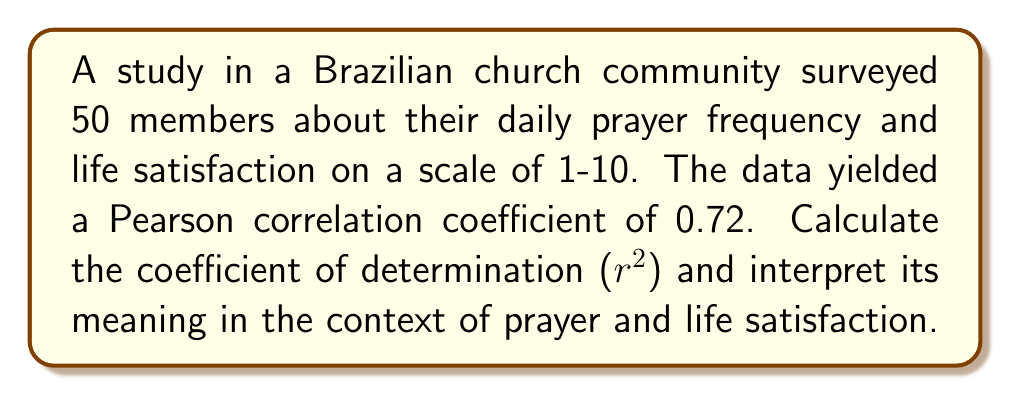Can you answer this question? To solve this problem, we'll follow these steps:

1. Recall that the coefficient of determination ($r^2$) is the square of the Pearson correlation coefficient ($r$).

2. Calculate $r^2$:
   $r^2 = (0.72)^2 = 0.5184$

3. Interpret the meaning:
   The coefficient of determination represents the proportion of variance in the dependent variable (life satisfaction) that is predictable from the independent variable (prayer frequency).

4. Convert to percentage:
   $0.5184 \times 100\% = 51.84\%$

5. Interpretation in context:
   Approximately 51.84% of the variation in reported life satisfaction levels can be explained by the variation in daily prayer frequency among the surveyed church members.

This result suggests a moderate to strong positive relationship between prayer frequency and life satisfaction in this Brazilian church community, aligning with the belief that spiritual practices can contribute to overall well-being.
Answer: $r^2 = 0.5184$, indicating 51.84% of variation in life satisfaction is explained by prayer frequency. 